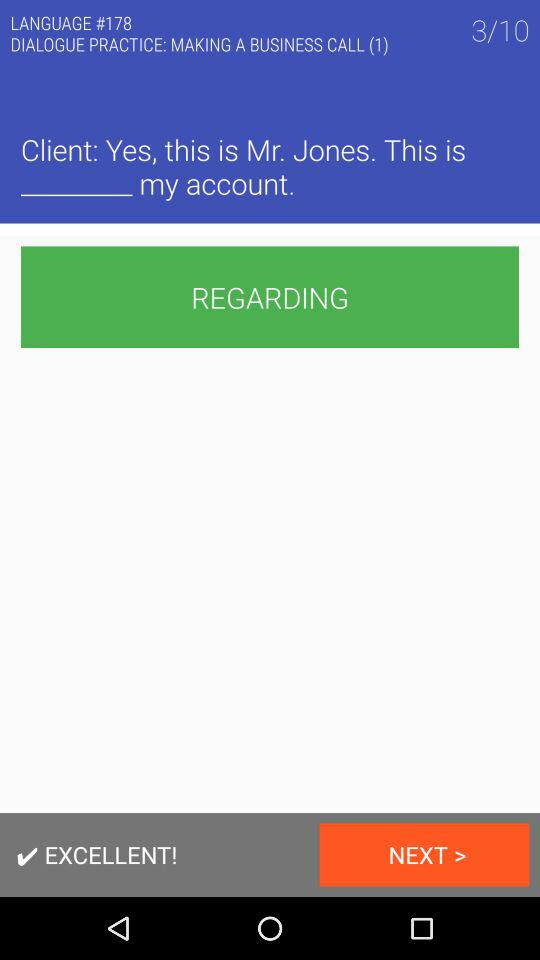What is the number of slides? The number of slides is 10. 